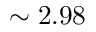Convert formula to latex. <formula><loc_0><loc_0><loc_500><loc_500>\sim 2 . 9 8</formula> 